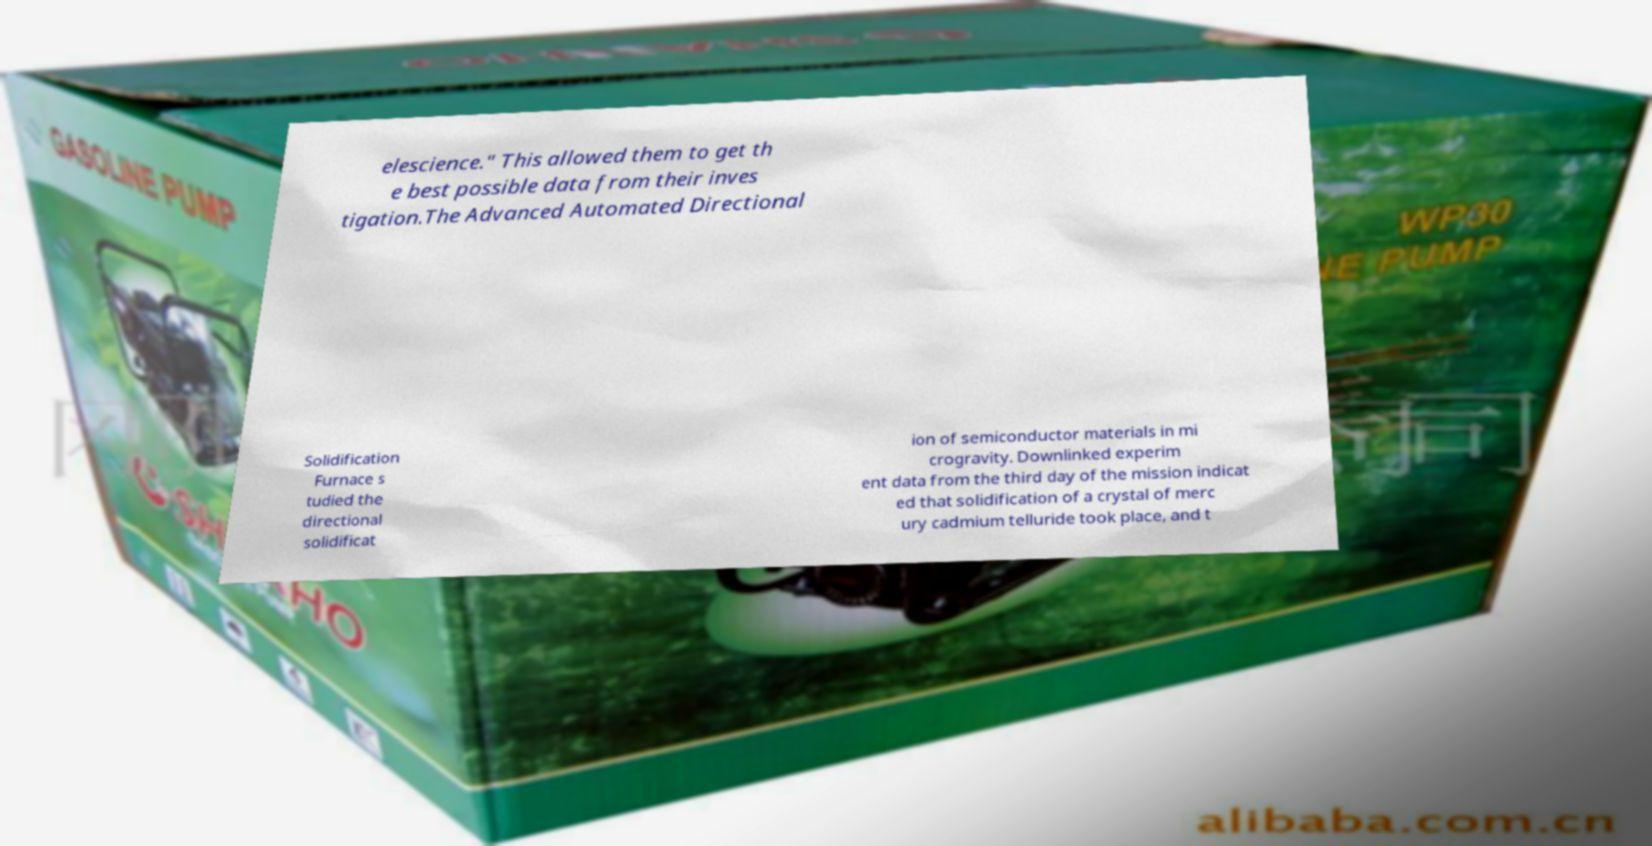Could you extract and type out the text from this image? elescience." This allowed them to get th e best possible data from their inves tigation.The Advanced Automated Directional Solidification Furnace s tudied the directional solidificat ion of semiconductor materials in mi crogravity. Downlinked experim ent data from the third day of the mission indicat ed that solidification of a crystal of merc ury cadmium telluride took place, and t 